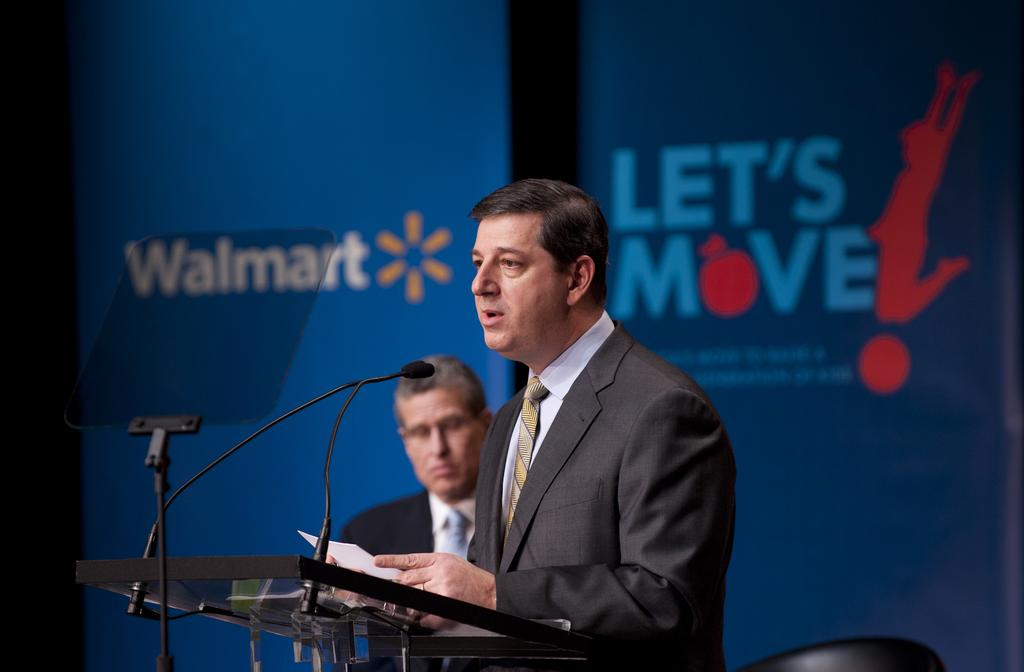How many people are in the image? There are persons standing in the image. What is the person at the lectern doing? The person at the lectern is standing and holding a paper. What can be seen in the background of the image? There are advertisements visible in the background of the image. How many beads are on the development in the image? There is no development or beads present in the image. What is the mass of the person standing at the lectern? The mass of the person standing at the lectern cannot be determined from the image. 